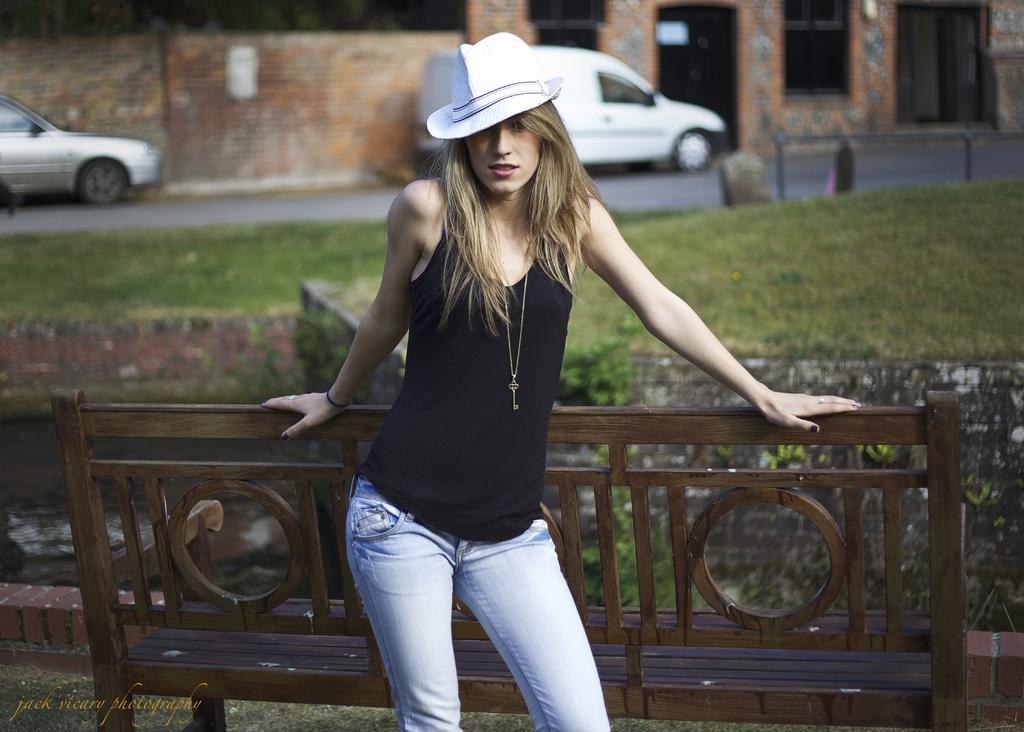Can you describe this image briefly? As we can see in the image in the front there is a woman wearing black color dress and white color hat. There is grass, car and a building. 